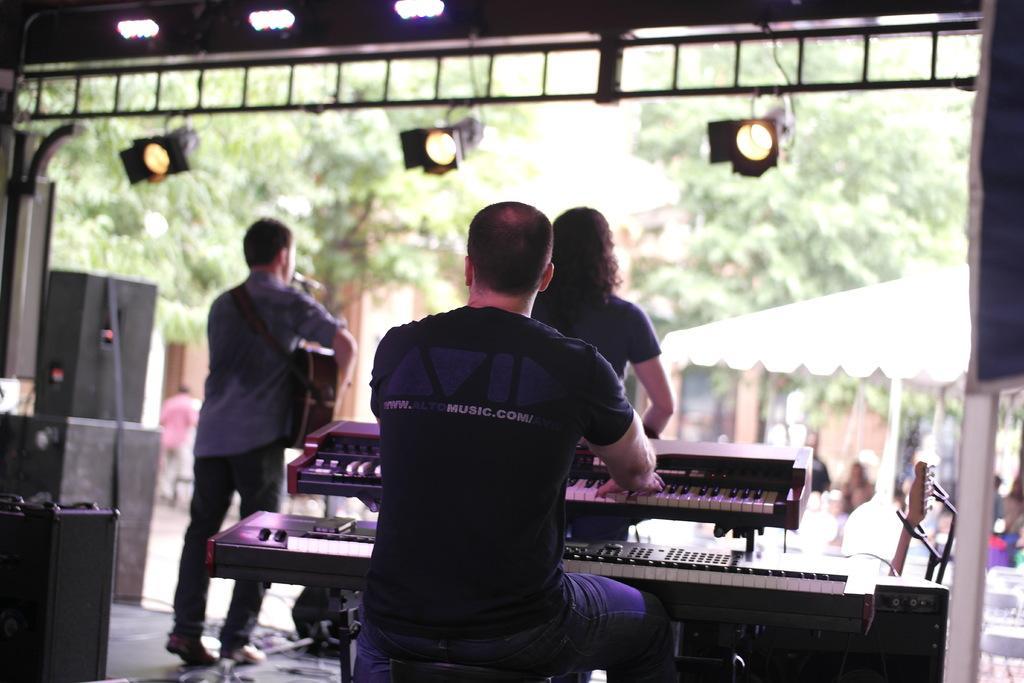Can you describe this image briefly? In this image there are three person on the stage. In front the person is playing the piano. On the left side the person is holding the guitar. At the back side we can see trees. 